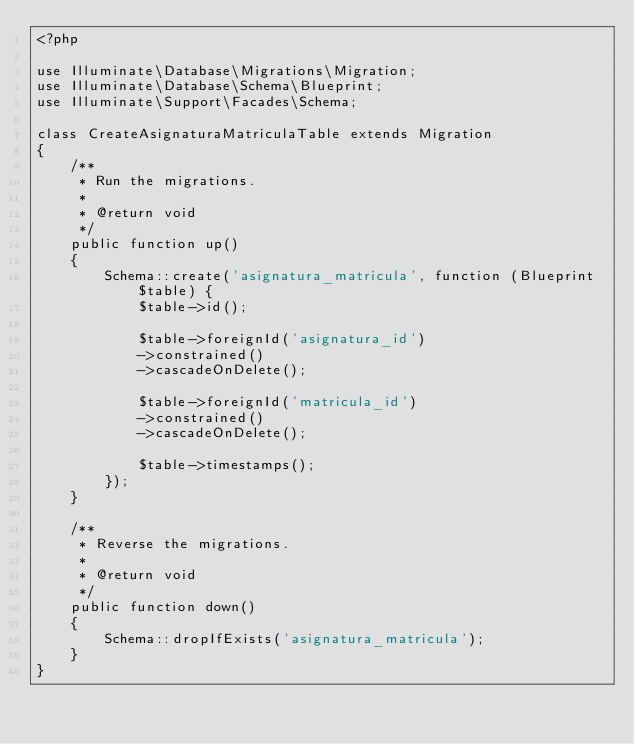<code> <loc_0><loc_0><loc_500><loc_500><_PHP_><?php

use Illuminate\Database\Migrations\Migration;
use Illuminate\Database\Schema\Blueprint;
use Illuminate\Support\Facades\Schema;

class CreateAsignaturaMatriculaTable extends Migration
{
    /**
     * Run the migrations.
     *
     * @return void
     */
    public function up()
    {
        Schema::create('asignatura_matricula', function (Blueprint $table) {
            $table->id();

            $table->foreignId('asignatura_id')
            ->constrained()
            ->cascadeOnDelete();
                        
            $table->foreignId('matricula_id')
            ->constrained()
            ->cascadeOnDelete();

            $table->timestamps();
        });
    }

    /**
     * Reverse the migrations.
     *
     * @return void
     */
    public function down()
    {
        Schema::dropIfExists('asignatura_matricula');
    }
}
</code> 